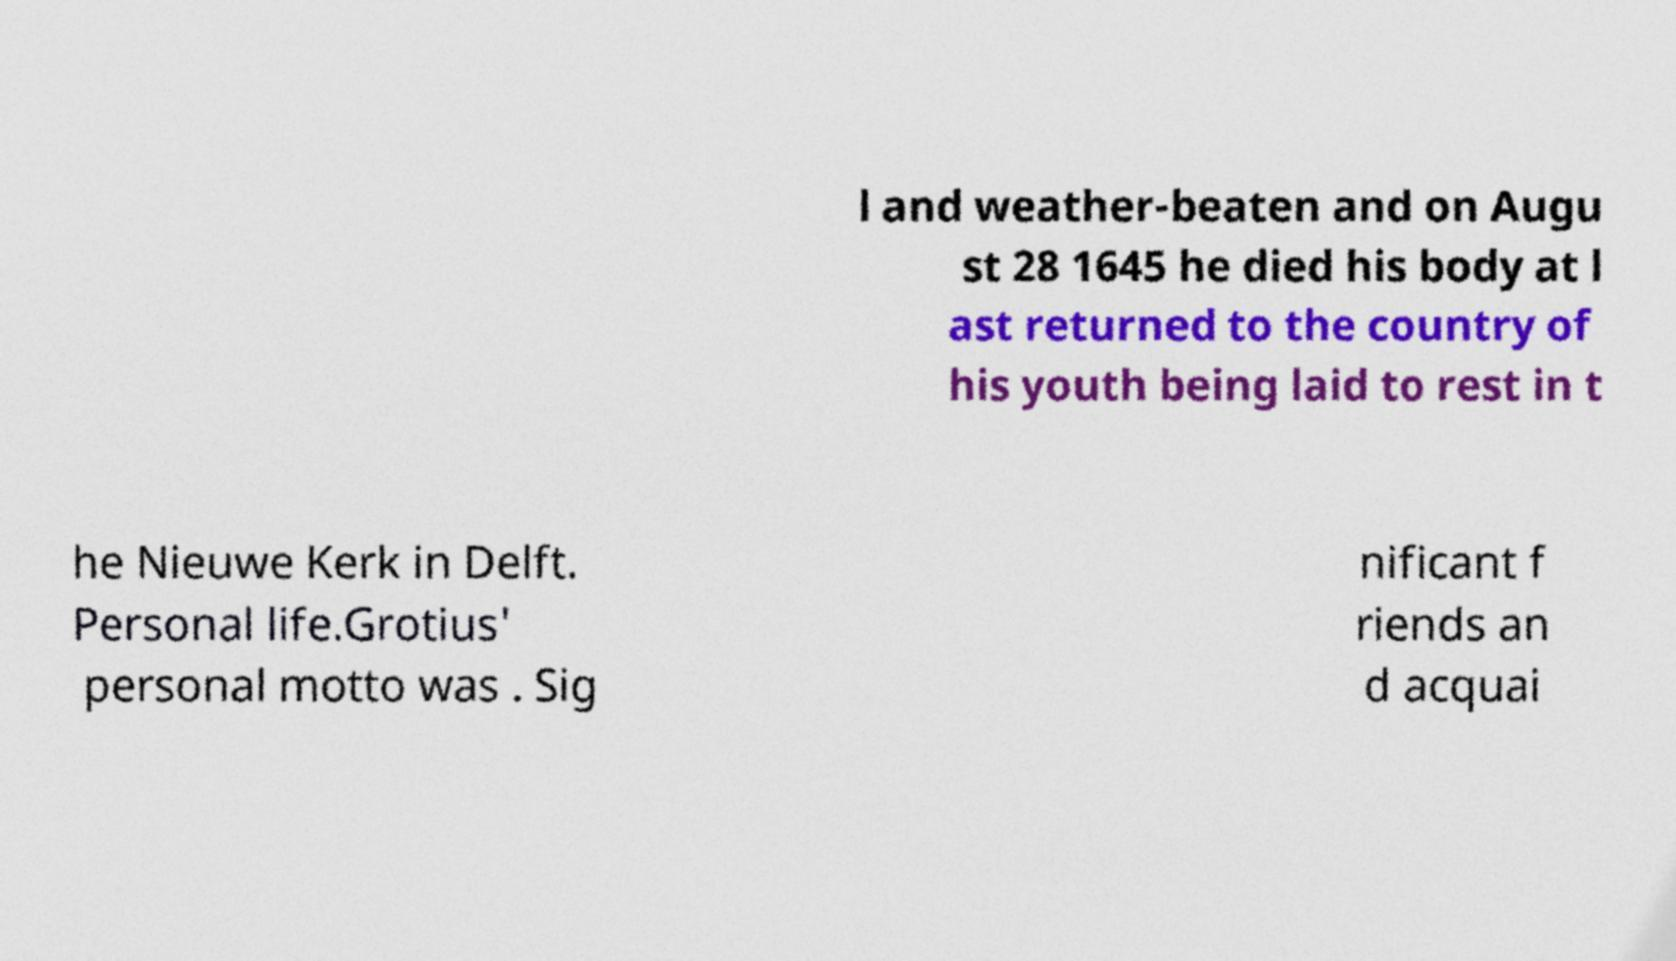Please read and relay the text visible in this image. What does it say? l and weather-beaten and on Augu st 28 1645 he died his body at l ast returned to the country of his youth being laid to rest in t he Nieuwe Kerk in Delft. Personal life.Grotius' personal motto was . Sig nificant f riends an d acquai 